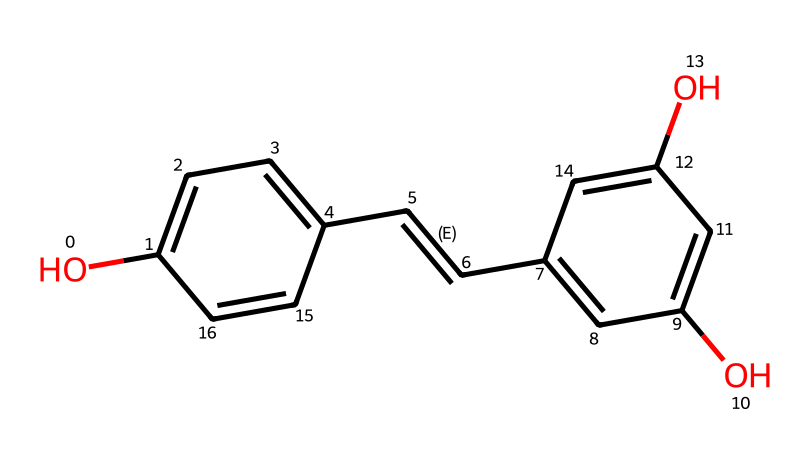What is the molecular formula of resveratrol? To determine the molecular formula, we can count the number of each type of atom in the SMILES representation. The structure contains 14 carbon atoms, 12 hydrogen atoms, and 4 oxygen atoms. Hence, the molecular formula is C14H12O4.
Answer: C14H12O4 How many hydroxyl (–OH) groups are present in the structure? The hydroxyl groups are indicated by the "O" atoms connected to hydrogen (–OH) in the SMILES representation. There are a total of 3 hydroxyl groups in the chemical structure.
Answer: 3 What type of bond connects the two aromatic rings in resveratrol? The two aromatic rings in the structure are connected by a double bond (indicated by "/C=C/"). This means that a carbon-carbon double bond links the rings.
Answer: double bond What role do the hydroxyl groups play in resveratrol's function as an antioxidant? Hydroxyl groups have the capacity to donate hydrogen atoms, which helps neutralize free radicals, thereby conferring antioxidant properties to resveratrol.
Answer: neutralize free radicals What is the significance of the double bond between the rings in terms of stability? The presence of a double bond can influence the stability and reactivity of the compound. In this case, it allows for increased electron delocalization, which can enhance the antioxidant activity of resveratrol.
Answer: increased electron delocalization How many rings are present in the chemical structure of resveratrol? By analyzing the structure, we can identify that there are two distinct aromatic rings in the compound.
Answer: 2 Which functional groups are primarily responsible for resveratrol's solubility in alcohol? The hydroxyl groups (–OH) present in the structure increase the polarity of resveratrol, thus enhancing its solubility in alcohol solutions.
Answer: hydroxyl groups 